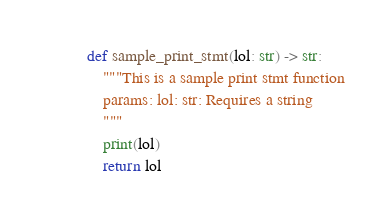<code> <loc_0><loc_0><loc_500><loc_500><_Python_>def sample_print_stmt(lol: str) -> str:
    """This is a sample print stmt function
    params: lol: str: Requires a string
    """
    print(lol)
    return lol
</code> 